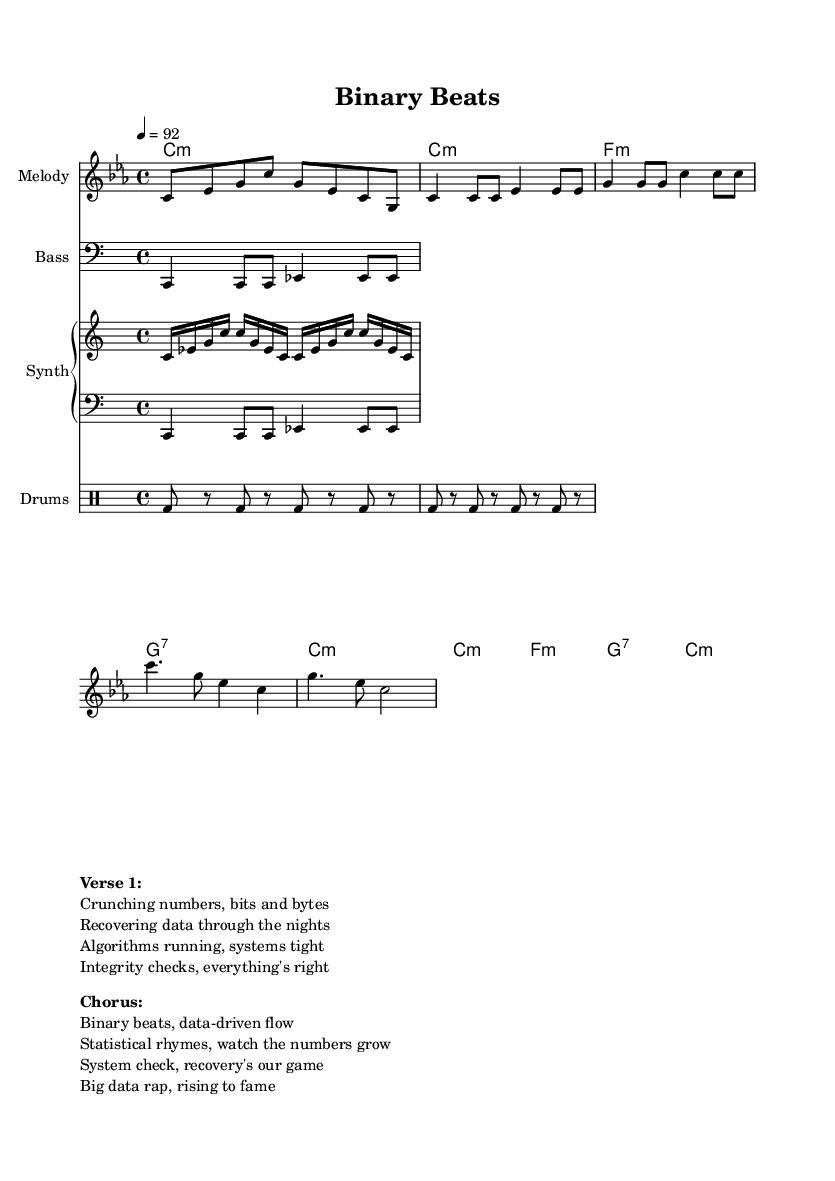What is the key signature of this music? The key signature is C minor, which has three flats (B flat, E flat, and A flat). It indicates that the piece is centered around C as the tonic note.
Answer: C minor What is the time signature of this piece? The time signature is 4/4, which means there are four beats per measure and the quarter note gets one beat. This is a common time signature for rap music, providing a steady rhythmic feel.
Answer: 4/4 What is the tempo marking in this sheet music? The tempo marking indicates a speed of 92 beats per minute, providing a moderately slow pace that is typical for many rap verses.
Answer: 92 How many different musical sections are present in the composition? The composition includes an Intro, Verse, and Chorus, allowing for diverse musical development and structure characteristic of rap songs.
Answer: 3 What are the main themes expressed in the lyrics of the verse? The lyrics focus on themes of data recovery, algorithm efficiency, and system integrity, reflecting a blend of technology and rap culture.
Answer: Data recovery and algorithms What type of patterns are used in the drum section? The drum section features a basic repeated kick drum pattern, which provides a solid rhythmic foundation essential for the energetic flow of rap music.
Answer: Kick drum pattern How do the lyrics relate to the musical structure in rap? The lyrics are intertwined with the rhythmic structure of the music, as they are designed to fit the beats and phrases laid out in the melody and harmony, enhancing the overall flow and delivery.
Answer: Rhythmic structure 